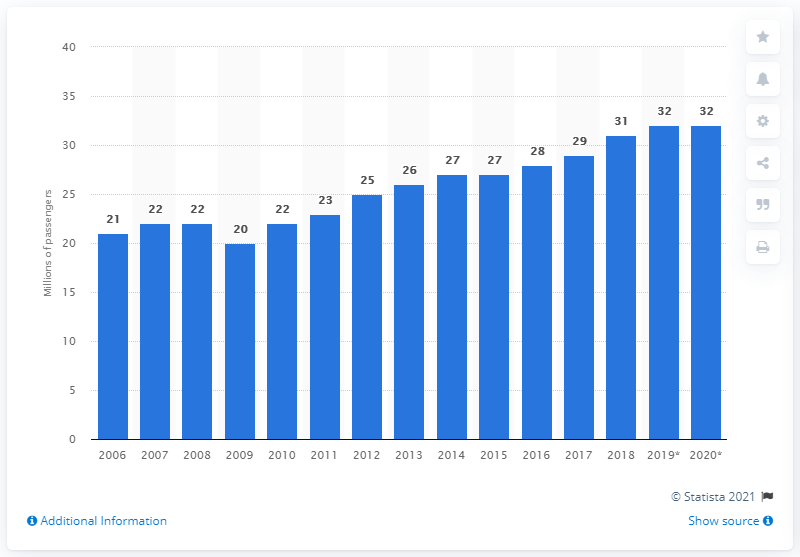Give some essential details in this illustration. In 2019, a total of 32 million transborder air passengers traveled to or from the United States. 